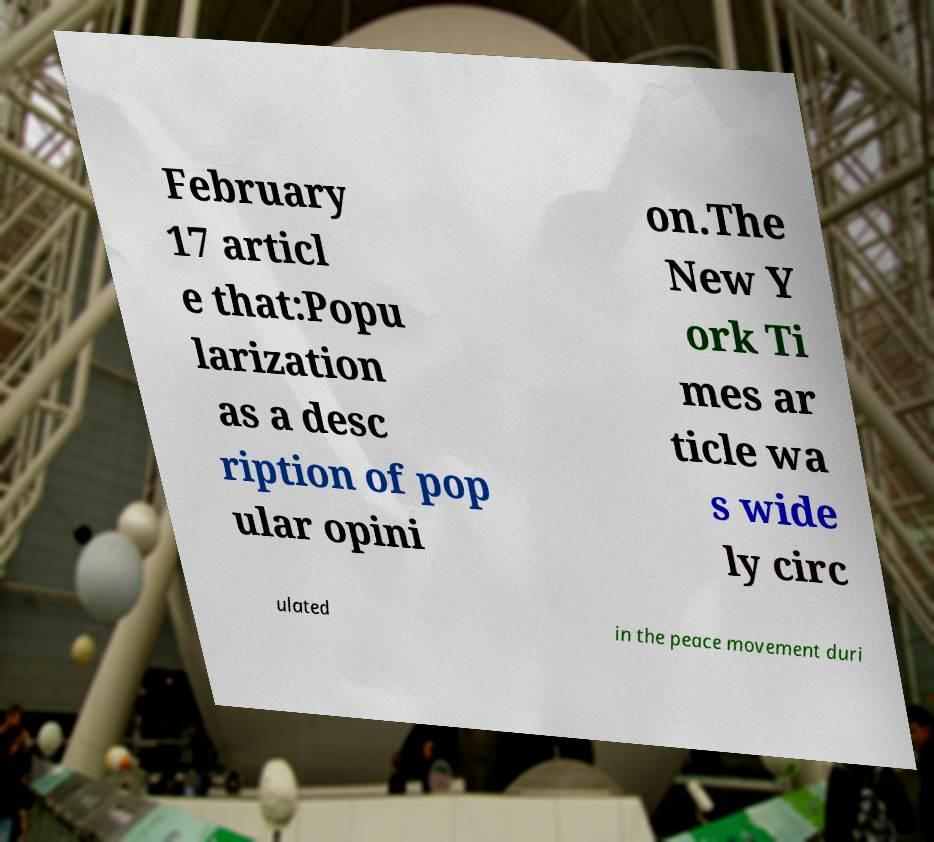Can you accurately transcribe the text from the provided image for me? February 17 articl e that:Popu larization as a desc ription of pop ular opini on.The New Y ork Ti mes ar ticle wa s wide ly circ ulated in the peace movement duri 